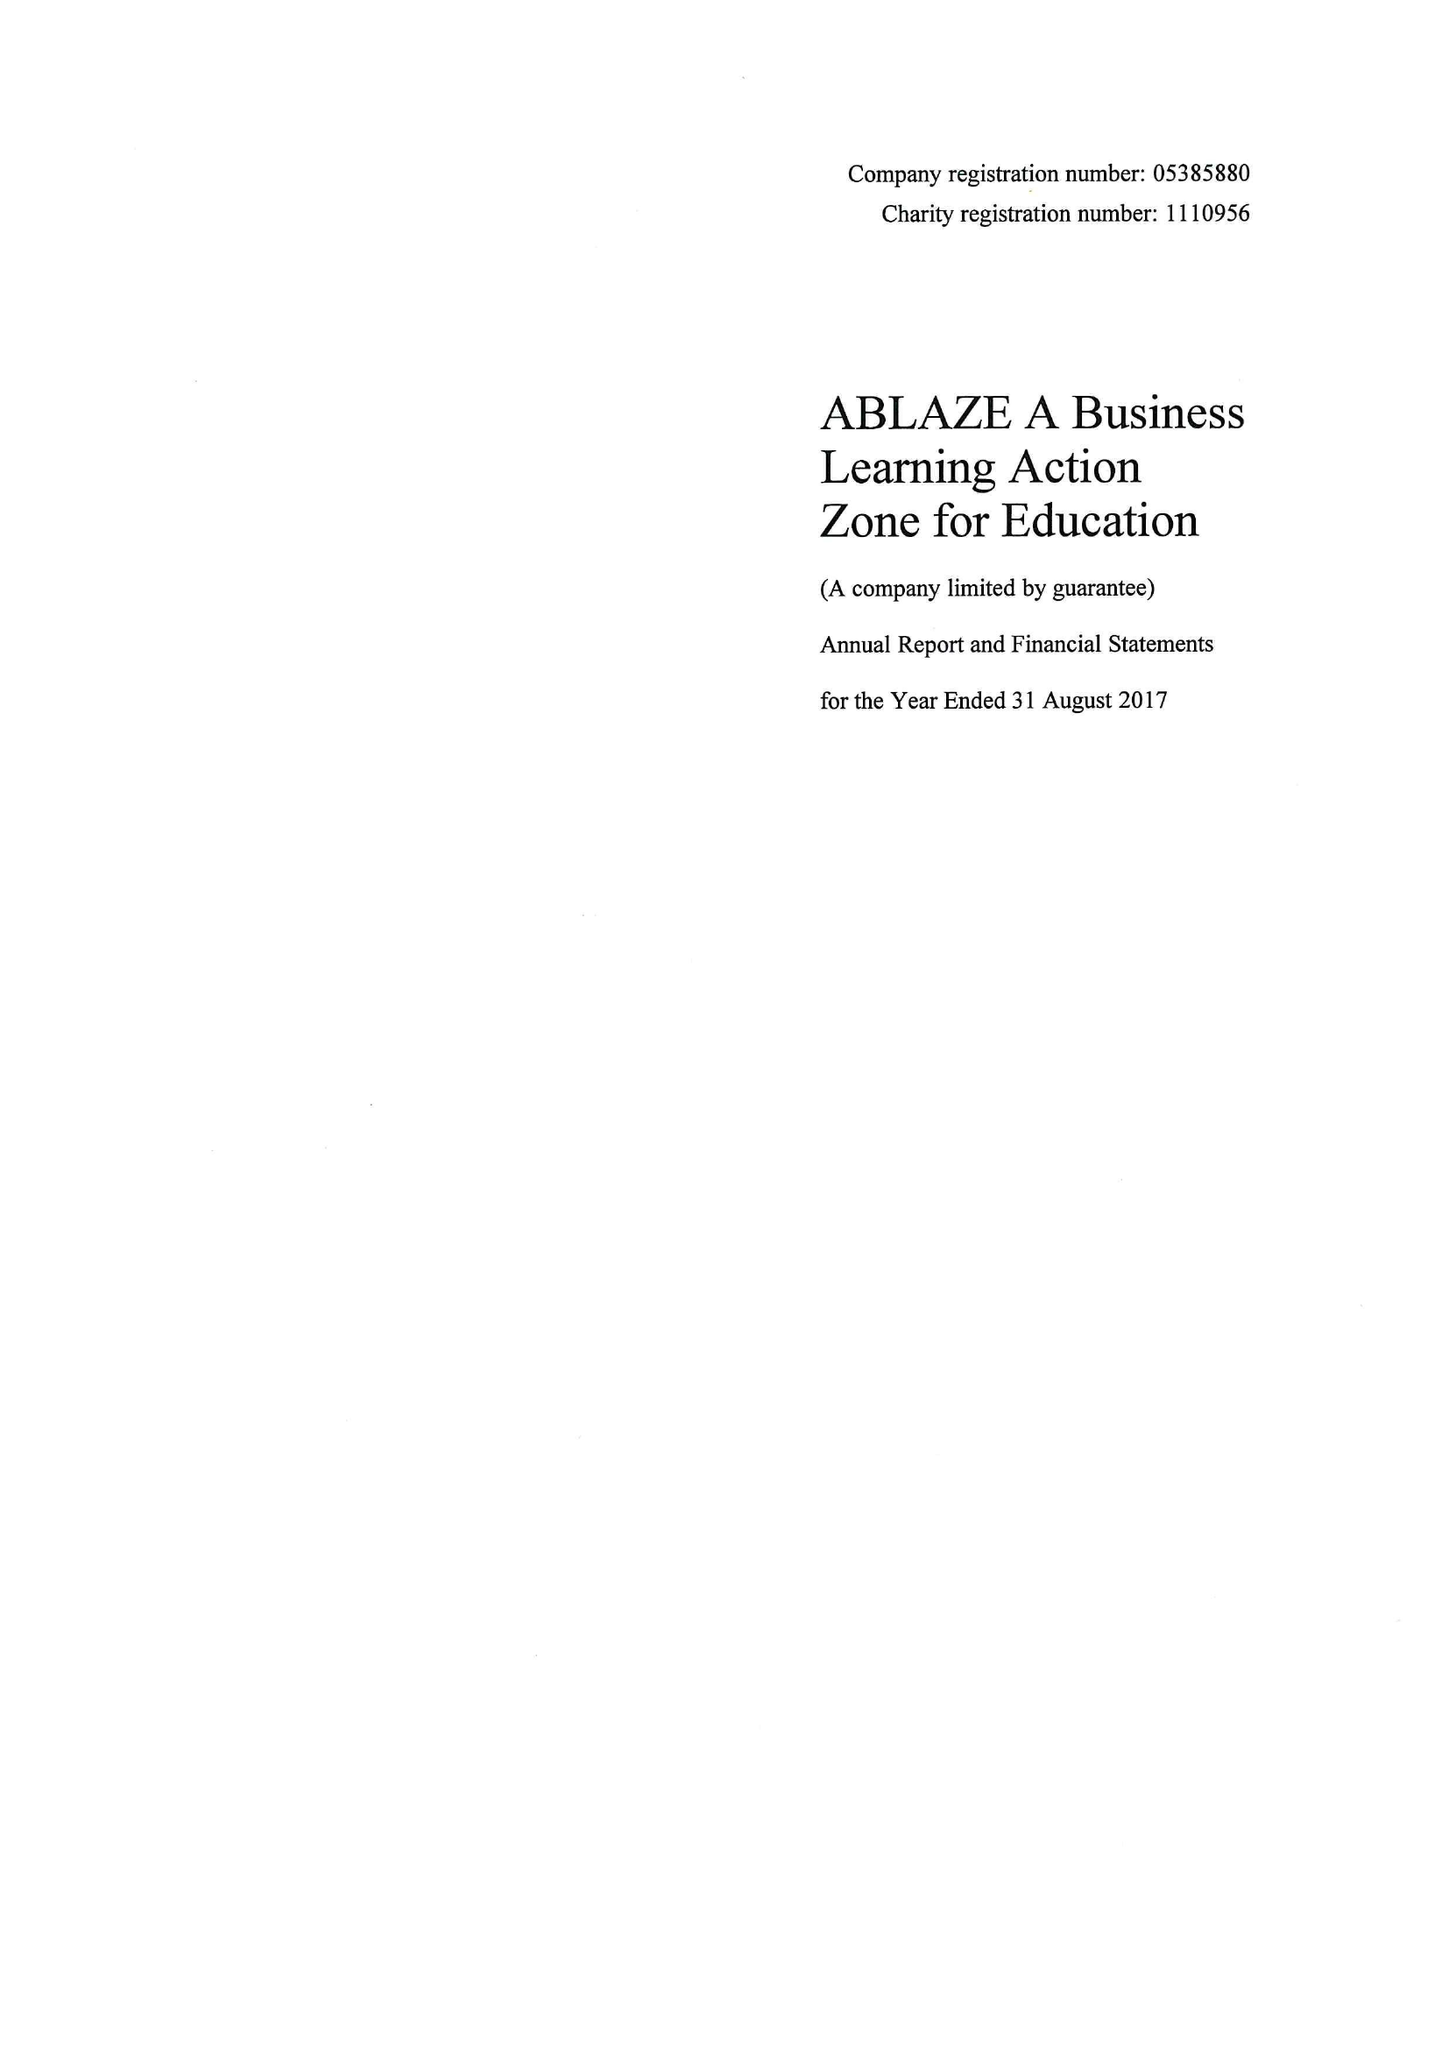What is the value for the report_date?
Answer the question using a single word or phrase. 2017-08-31 